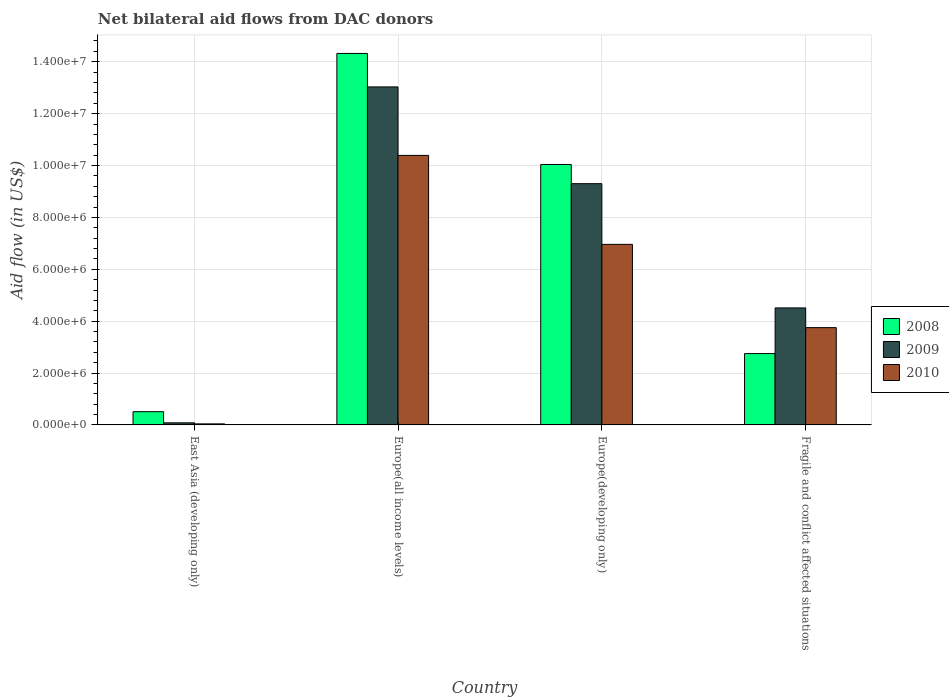How many different coloured bars are there?
Your answer should be very brief. 3. How many groups of bars are there?
Give a very brief answer. 4. Are the number of bars on each tick of the X-axis equal?
Make the answer very short. Yes. How many bars are there on the 2nd tick from the left?
Make the answer very short. 3. How many bars are there on the 3rd tick from the right?
Offer a very short reply. 3. What is the label of the 1st group of bars from the left?
Ensure brevity in your answer.  East Asia (developing only). In how many cases, is the number of bars for a given country not equal to the number of legend labels?
Provide a succinct answer. 0. What is the net bilateral aid flow in 2010 in Europe(all income levels)?
Offer a terse response. 1.04e+07. Across all countries, what is the maximum net bilateral aid flow in 2009?
Your answer should be compact. 1.30e+07. In which country was the net bilateral aid flow in 2009 maximum?
Your response must be concise. Europe(all income levels). In which country was the net bilateral aid flow in 2009 minimum?
Provide a succinct answer. East Asia (developing only). What is the total net bilateral aid flow in 2008 in the graph?
Your response must be concise. 2.76e+07. What is the difference between the net bilateral aid flow in 2008 in Europe(all income levels) and that in Europe(developing only)?
Make the answer very short. 4.28e+06. What is the difference between the net bilateral aid flow in 2008 in Europe(developing only) and the net bilateral aid flow in 2009 in Fragile and conflict affected situations?
Offer a terse response. 5.53e+06. What is the average net bilateral aid flow in 2009 per country?
Offer a very short reply. 6.73e+06. What is the difference between the net bilateral aid flow of/in 2010 and net bilateral aid flow of/in 2008 in Europe(developing only)?
Make the answer very short. -3.08e+06. What is the ratio of the net bilateral aid flow in 2008 in East Asia (developing only) to that in Europe(developing only)?
Make the answer very short. 0.05. Is the net bilateral aid flow in 2009 in Europe(developing only) less than that in Fragile and conflict affected situations?
Give a very brief answer. No. What is the difference between the highest and the second highest net bilateral aid flow in 2010?
Your response must be concise. 6.64e+06. What is the difference between the highest and the lowest net bilateral aid flow in 2008?
Ensure brevity in your answer.  1.38e+07. What does the 3rd bar from the left in Fragile and conflict affected situations represents?
Provide a succinct answer. 2010. What does the 1st bar from the right in Europe(all income levels) represents?
Ensure brevity in your answer.  2010. Is it the case that in every country, the sum of the net bilateral aid flow in 2010 and net bilateral aid flow in 2009 is greater than the net bilateral aid flow in 2008?
Offer a very short reply. No. How many bars are there?
Provide a short and direct response. 12. Are all the bars in the graph horizontal?
Offer a very short reply. No. Does the graph contain any zero values?
Your answer should be compact. No. How many legend labels are there?
Your answer should be very brief. 3. How are the legend labels stacked?
Provide a short and direct response. Vertical. What is the title of the graph?
Your answer should be compact. Net bilateral aid flows from DAC donors. Does "1997" appear as one of the legend labels in the graph?
Provide a succinct answer. No. What is the label or title of the Y-axis?
Your response must be concise. Aid flow (in US$). What is the Aid flow (in US$) of 2008 in East Asia (developing only)?
Provide a short and direct response. 5.10e+05. What is the Aid flow (in US$) of 2008 in Europe(all income levels)?
Provide a succinct answer. 1.43e+07. What is the Aid flow (in US$) of 2009 in Europe(all income levels)?
Offer a terse response. 1.30e+07. What is the Aid flow (in US$) in 2010 in Europe(all income levels)?
Your answer should be very brief. 1.04e+07. What is the Aid flow (in US$) of 2008 in Europe(developing only)?
Offer a terse response. 1.00e+07. What is the Aid flow (in US$) of 2009 in Europe(developing only)?
Your answer should be very brief. 9.30e+06. What is the Aid flow (in US$) of 2010 in Europe(developing only)?
Your answer should be very brief. 6.96e+06. What is the Aid flow (in US$) of 2008 in Fragile and conflict affected situations?
Keep it short and to the point. 2.75e+06. What is the Aid flow (in US$) in 2009 in Fragile and conflict affected situations?
Give a very brief answer. 4.51e+06. What is the Aid flow (in US$) in 2010 in Fragile and conflict affected situations?
Keep it short and to the point. 3.75e+06. Across all countries, what is the maximum Aid flow (in US$) in 2008?
Ensure brevity in your answer.  1.43e+07. Across all countries, what is the maximum Aid flow (in US$) of 2009?
Provide a short and direct response. 1.30e+07. Across all countries, what is the maximum Aid flow (in US$) in 2010?
Give a very brief answer. 1.04e+07. Across all countries, what is the minimum Aid flow (in US$) in 2008?
Offer a very short reply. 5.10e+05. Across all countries, what is the minimum Aid flow (in US$) of 2009?
Your answer should be very brief. 8.00e+04. What is the total Aid flow (in US$) in 2008 in the graph?
Offer a very short reply. 2.76e+07. What is the total Aid flow (in US$) of 2009 in the graph?
Make the answer very short. 2.69e+07. What is the total Aid flow (in US$) of 2010 in the graph?
Ensure brevity in your answer.  2.11e+07. What is the difference between the Aid flow (in US$) of 2008 in East Asia (developing only) and that in Europe(all income levels)?
Your answer should be compact. -1.38e+07. What is the difference between the Aid flow (in US$) in 2009 in East Asia (developing only) and that in Europe(all income levels)?
Provide a short and direct response. -1.30e+07. What is the difference between the Aid flow (in US$) of 2010 in East Asia (developing only) and that in Europe(all income levels)?
Offer a terse response. -1.04e+07. What is the difference between the Aid flow (in US$) in 2008 in East Asia (developing only) and that in Europe(developing only)?
Provide a succinct answer. -9.53e+06. What is the difference between the Aid flow (in US$) of 2009 in East Asia (developing only) and that in Europe(developing only)?
Provide a succinct answer. -9.22e+06. What is the difference between the Aid flow (in US$) of 2010 in East Asia (developing only) and that in Europe(developing only)?
Provide a succinct answer. -6.92e+06. What is the difference between the Aid flow (in US$) in 2008 in East Asia (developing only) and that in Fragile and conflict affected situations?
Make the answer very short. -2.24e+06. What is the difference between the Aid flow (in US$) of 2009 in East Asia (developing only) and that in Fragile and conflict affected situations?
Make the answer very short. -4.43e+06. What is the difference between the Aid flow (in US$) in 2010 in East Asia (developing only) and that in Fragile and conflict affected situations?
Offer a very short reply. -3.71e+06. What is the difference between the Aid flow (in US$) in 2008 in Europe(all income levels) and that in Europe(developing only)?
Keep it short and to the point. 4.28e+06. What is the difference between the Aid flow (in US$) of 2009 in Europe(all income levels) and that in Europe(developing only)?
Provide a succinct answer. 3.73e+06. What is the difference between the Aid flow (in US$) of 2010 in Europe(all income levels) and that in Europe(developing only)?
Your answer should be compact. 3.43e+06. What is the difference between the Aid flow (in US$) of 2008 in Europe(all income levels) and that in Fragile and conflict affected situations?
Ensure brevity in your answer.  1.16e+07. What is the difference between the Aid flow (in US$) of 2009 in Europe(all income levels) and that in Fragile and conflict affected situations?
Ensure brevity in your answer.  8.52e+06. What is the difference between the Aid flow (in US$) of 2010 in Europe(all income levels) and that in Fragile and conflict affected situations?
Your answer should be very brief. 6.64e+06. What is the difference between the Aid flow (in US$) of 2008 in Europe(developing only) and that in Fragile and conflict affected situations?
Your response must be concise. 7.29e+06. What is the difference between the Aid flow (in US$) in 2009 in Europe(developing only) and that in Fragile and conflict affected situations?
Offer a terse response. 4.79e+06. What is the difference between the Aid flow (in US$) of 2010 in Europe(developing only) and that in Fragile and conflict affected situations?
Ensure brevity in your answer.  3.21e+06. What is the difference between the Aid flow (in US$) of 2008 in East Asia (developing only) and the Aid flow (in US$) of 2009 in Europe(all income levels)?
Provide a short and direct response. -1.25e+07. What is the difference between the Aid flow (in US$) in 2008 in East Asia (developing only) and the Aid flow (in US$) in 2010 in Europe(all income levels)?
Provide a succinct answer. -9.88e+06. What is the difference between the Aid flow (in US$) of 2009 in East Asia (developing only) and the Aid flow (in US$) of 2010 in Europe(all income levels)?
Your answer should be compact. -1.03e+07. What is the difference between the Aid flow (in US$) in 2008 in East Asia (developing only) and the Aid flow (in US$) in 2009 in Europe(developing only)?
Provide a short and direct response. -8.79e+06. What is the difference between the Aid flow (in US$) of 2008 in East Asia (developing only) and the Aid flow (in US$) of 2010 in Europe(developing only)?
Your response must be concise. -6.45e+06. What is the difference between the Aid flow (in US$) of 2009 in East Asia (developing only) and the Aid flow (in US$) of 2010 in Europe(developing only)?
Provide a succinct answer. -6.88e+06. What is the difference between the Aid flow (in US$) in 2008 in East Asia (developing only) and the Aid flow (in US$) in 2009 in Fragile and conflict affected situations?
Your answer should be very brief. -4.00e+06. What is the difference between the Aid flow (in US$) of 2008 in East Asia (developing only) and the Aid flow (in US$) of 2010 in Fragile and conflict affected situations?
Make the answer very short. -3.24e+06. What is the difference between the Aid flow (in US$) of 2009 in East Asia (developing only) and the Aid flow (in US$) of 2010 in Fragile and conflict affected situations?
Offer a very short reply. -3.67e+06. What is the difference between the Aid flow (in US$) in 2008 in Europe(all income levels) and the Aid flow (in US$) in 2009 in Europe(developing only)?
Your answer should be very brief. 5.02e+06. What is the difference between the Aid flow (in US$) of 2008 in Europe(all income levels) and the Aid flow (in US$) of 2010 in Europe(developing only)?
Offer a very short reply. 7.36e+06. What is the difference between the Aid flow (in US$) of 2009 in Europe(all income levels) and the Aid flow (in US$) of 2010 in Europe(developing only)?
Offer a very short reply. 6.07e+06. What is the difference between the Aid flow (in US$) of 2008 in Europe(all income levels) and the Aid flow (in US$) of 2009 in Fragile and conflict affected situations?
Your answer should be compact. 9.81e+06. What is the difference between the Aid flow (in US$) in 2008 in Europe(all income levels) and the Aid flow (in US$) in 2010 in Fragile and conflict affected situations?
Ensure brevity in your answer.  1.06e+07. What is the difference between the Aid flow (in US$) in 2009 in Europe(all income levels) and the Aid flow (in US$) in 2010 in Fragile and conflict affected situations?
Offer a very short reply. 9.28e+06. What is the difference between the Aid flow (in US$) of 2008 in Europe(developing only) and the Aid flow (in US$) of 2009 in Fragile and conflict affected situations?
Keep it short and to the point. 5.53e+06. What is the difference between the Aid flow (in US$) of 2008 in Europe(developing only) and the Aid flow (in US$) of 2010 in Fragile and conflict affected situations?
Your answer should be very brief. 6.29e+06. What is the difference between the Aid flow (in US$) in 2009 in Europe(developing only) and the Aid flow (in US$) in 2010 in Fragile and conflict affected situations?
Offer a very short reply. 5.55e+06. What is the average Aid flow (in US$) in 2008 per country?
Offer a very short reply. 6.90e+06. What is the average Aid flow (in US$) in 2009 per country?
Provide a succinct answer. 6.73e+06. What is the average Aid flow (in US$) in 2010 per country?
Provide a short and direct response. 5.28e+06. What is the difference between the Aid flow (in US$) in 2008 and Aid flow (in US$) in 2010 in East Asia (developing only)?
Provide a short and direct response. 4.70e+05. What is the difference between the Aid flow (in US$) in 2009 and Aid flow (in US$) in 2010 in East Asia (developing only)?
Ensure brevity in your answer.  4.00e+04. What is the difference between the Aid flow (in US$) in 2008 and Aid flow (in US$) in 2009 in Europe(all income levels)?
Offer a very short reply. 1.29e+06. What is the difference between the Aid flow (in US$) of 2008 and Aid flow (in US$) of 2010 in Europe(all income levels)?
Offer a very short reply. 3.93e+06. What is the difference between the Aid flow (in US$) of 2009 and Aid flow (in US$) of 2010 in Europe(all income levels)?
Your answer should be compact. 2.64e+06. What is the difference between the Aid flow (in US$) of 2008 and Aid flow (in US$) of 2009 in Europe(developing only)?
Your response must be concise. 7.40e+05. What is the difference between the Aid flow (in US$) in 2008 and Aid flow (in US$) in 2010 in Europe(developing only)?
Ensure brevity in your answer.  3.08e+06. What is the difference between the Aid flow (in US$) of 2009 and Aid flow (in US$) of 2010 in Europe(developing only)?
Make the answer very short. 2.34e+06. What is the difference between the Aid flow (in US$) of 2008 and Aid flow (in US$) of 2009 in Fragile and conflict affected situations?
Your response must be concise. -1.76e+06. What is the difference between the Aid flow (in US$) in 2009 and Aid flow (in US$) in 2010 in Fragile and conflict affected situations?
Provide a succinct answer. 7.60e+05. What is the ratio of the Aid flow (in US$) in 2008 in East Asia (developing only) to that in Europe(all income levels)?
Make the answer very short. 0.04. What is the ratio of the Aid flow (in US$) in 2009 in East Asia (developing only) to that in Europe(all income levels)?
Ensure brevity in your answer.  0.01. What is the ratio of the Aid flow (in US$) of 2010 in East Asia (developing only) to that in Europe(all income levels)?
Offer a terse response. 0. What is the ratio of the Aid flow (in US$) of 2008 in East Asia (developing only) to that in Europe(developing only)?
Make the answer very short. 0.05. What is the ratio of the Aid flow (in US$) in 2009 in East Asia (developing only) to that in Europe(developing only)?
Make the answer very short. 0.01. What is the ratio of the Aid flow (in US$) in 2010 in East Asia (developing only) to that in Europe(developing only)?
Your answer should be very brief. 0.01. What is the ratio of the Aid flow (in US$) in 2008 in East Asia (developing only) to that in Fragile and conflict affected situations?
Your answer should be very brief. 0.19. What is the ratio of the Aid flow (in US$) of 2009 in East Asia (developing only) to that in Fragile and conflict affected situations?
Provide a succinct answer. 0.02. What is the ratio of the Aid flow (in US$) of 2010 in East Asia (developing only) to that in Fragile and conflict affected situations?
Offer a very short reply. 0.01. What is the ratio of the Aid flow (in US$) of 2008 in Europe(all income levels) to that in Europe(developing only)?
Offer a very short reply. 1.43. What is the ratio of the Aid flow (in US$) in 2009 in Europe(all income levels) to that in Europe(developing only)?
Give a very brief answer. 1.4. What is the ratio of the Aid flow (in US$) of 2010 in Europe(all income levels) to that in Europe(developing only)?
Your answer should be compact. 1.49. What is the ratio of the Aid flow (in US$) of 2008 in Europe(all income levels) to that in Fragile and conflict affected situations?
Offer a very short reply. 5.21. What is the ratio of the Aid flow (in US$) of 2009 in Europe(all income levels) to that in Fragile and conflict affected situations?
Provide a short and direct response. 2.89. What is the ratio of the Aid flow (in US$) of 2010 in Europe(all income levels) to that in Fragile and conflict affected situations?
Ensure brevity in your answer.  2.77. What is the ratio of the Aid flow (in US$) in 2008 in Europe(developing only) to that in Fragile and conflict affected situations?
Offer a very short reply. 3.65. What is the ratio of the Aid flow (in US$) in 2009 in Europe(developing only) to that in Fragile and conflict affected situations?
Make the answer very short. 2.06. What is the ratio of the Aid flow (in US$) of 2010 in Europe(developing only) to that in Fragile and conflict affected situations?
Provide a succinct answer. 1.86. What is the difference between the highest and the second highest Aid flow (in US$) in 2008?
Offer a very short reply. 4.28e+06. What is the difference between the highest and the second highest Aid flow (in US$) in 2009?
Your response must be concise. 3.73e+06. What is the difference between the highest and the second highest Aid flow (in US$) of 2010?
Make the answer very short. 3.43e+06. What is the difference between the highest and the lowest Aid flow (in US$) of 2008?
Keep it short and to the point. 1.38e+07. What is the difference between the highest and the lowest Aid flow (in US$) in 2009?
Your answer should be compact. 1.30e+07. What is the difference between the highest and the lowest Aid flow (in US$) of 2010?
Your answer should be very brief. 1.04e+07. 